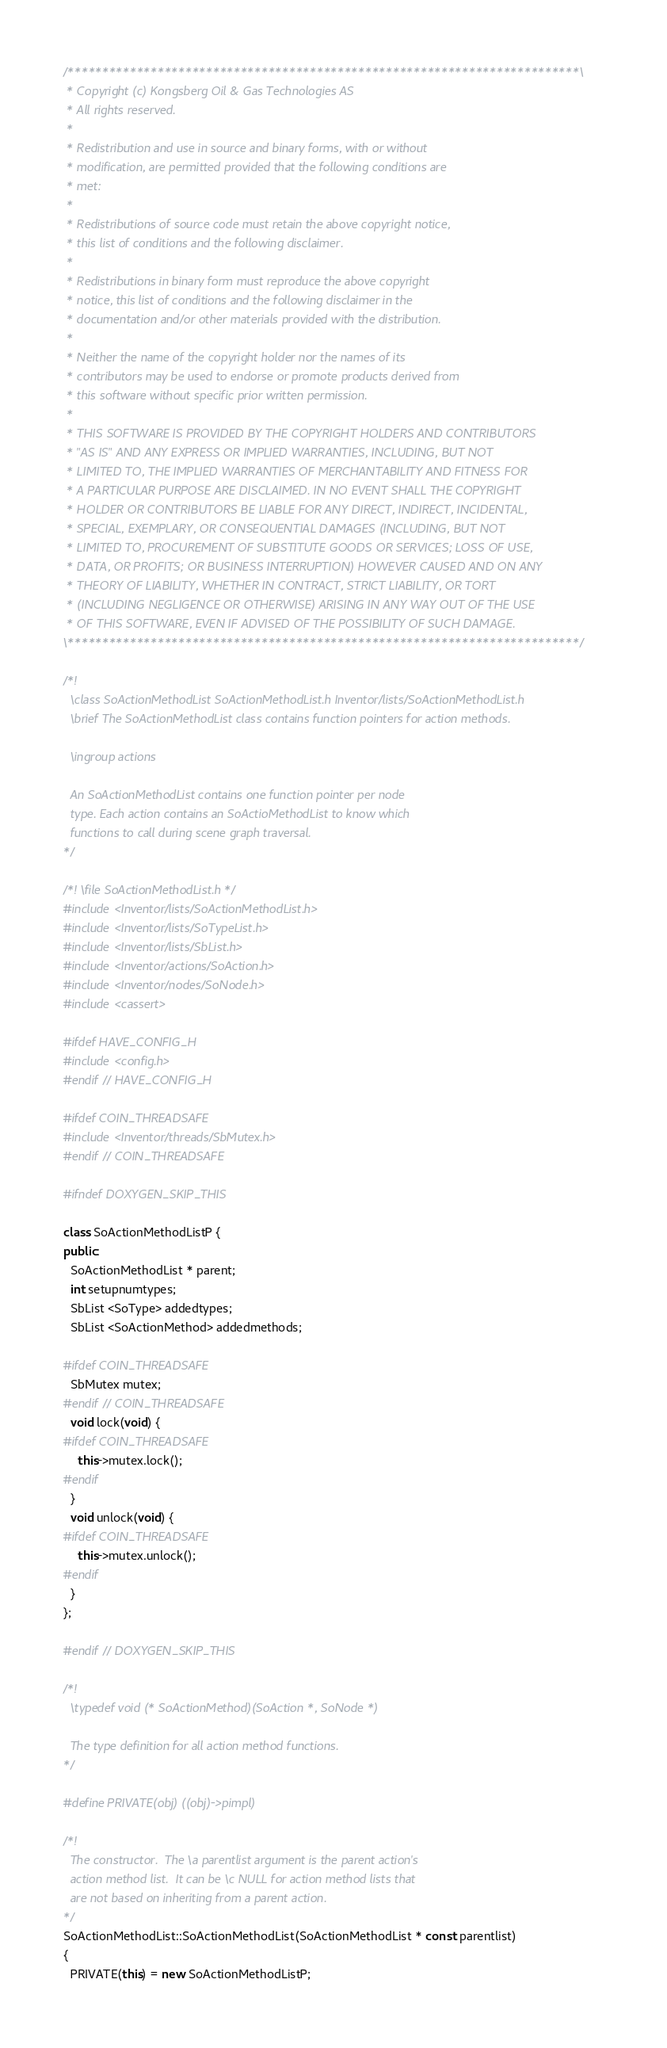Convert code to text. <code><loc_0><loc_0><loc_500><loc_500><_C++_>/**************************************************************************\
 * Copyright (c) Kongsberg Oil & Gas Technologies AS
 * All rights reserved.
 * 
 * Redistribution and use in source and binary forms, with or without
 * modification, are permitted provided that the following conditions are
 * met:
 * 
 * Redistributions of source code must retain the above copyright notice,
 * this list of conditions and the following disclaimer.
 * 
 * Redistributions in binary form must reproduce the above copyright
 * notice, this list of conditions and the following disclaimer in the
 * documentation and/or other materials provided with the distribution.
 * 
 * Neither the name of the copyright holder nor the names of its
 * contributors may be used to endorse or promote products derived from
 * this software without specific prior written permission.
 * 
 * THIS SOFTWARE IS PROVIDED BY THE COPYRIGHT HOLDERS AND CONTRIBUTORS
 * "AS IS" AND ANY EXPRESS OR IMPLIED WARRANTIES, INCLUDING, BUT NOT
 * LIMITED TO, THE IMPLIED WARRANTIES OF MERCHANTABILITY AND FITNESS FOR
 * A PARTICULAR PURPOSE ARE DISCLAIMED. IN NO EVENT SHALL THE COPYRIGHT
 * HOLDER OR CONTRIBUTORS BE LIABLE FOR ANY DIRECT, INDIRECT, INCIDENTAL,
 * SPECIAL, EXEMPLARY, OR CONSEQUENTIAL DAMAGES (INCLUDING, BUT NOT
 * LIMITED TO, PROCUREMENT OF SUBSTITUTE GOODS OR SERVICES; LOSS OF USE,
 * DATA, OR PROFITS; OR BUSINESS INTERRUPTION) HOWEVER CAUSED AND ON ANY
 * THEORY OF LIABILITY, WHETHER IN CONTRACT, STRICT LIABILITY, OR TORT
 * (INCLUDING NEGLIGENCE OR OTHERWISE) ARISING IN ANY WAY OUT OF THE USE
 * OF THIS SOFTWARE, EVEN IF ADVISED OF THE POSSIBILITY OF SUCH DAMAGE.
\**************************************************************************/

/*!
  \class SoActionMethodList SoActionMethodList.h Inventor/lists/SoActionMethodList.h
  \brief The SoActionMethodList class contains function pointers for action methods.

  \ingroup actions

  An SoActionMethodList contains one function pointer per node
  type. Each action contains an SoActioMethodList to know which
  functions to call during scene graph traversal.
*/

/*! \file SoActionMethodList.h */
#include <Inventor/lists/SoActionMethodList.h>
#include <Inventor/lists/SoTypeList.h>
#include <Inventor/lists/SbList.h>
#include <Inventor/actions/SoAction.h>
#include <Inventor/nodes/SoNode.h>
#include <cassert>

#ifdef HAVE_CONFIG_H
#include <config.h>
#endif // HAVE_CONFIG_H

#ifdef COIN_THREADSAFE
#include <Inventor/threads/SbMutex.h>
#endif // COIN_THREADSAFE

#ifndef DOXYGEN_SKIP_THIS

class SoActionMethodListP {
public:
  SoActionMethodList * parent;
  int setupnumtypes;
  SbList <SoType> addedtypes;
  SbList <SoActionMethod> addedmethods;

#ifdef COIN_THREADSAFE
  SbMutex mutex;
#endif // COIN_THREADSAFE
  void lock(void) {
#ifdef COIN_THREADSAFE
    this->mutex.lock();
#endif
  }
  void unlock(void) {
#ifdef COIN_THREADSAFE
    this->mutex.unlock();
#endif
  }
};

#endif // DOXYGEN_SKIP_THIS

/*!
  \typedef void (* SoActionMethod)(SoAction *, SoNode *)

  The type definition for all action method functions.
*/

#define PRIVATE(obj) ((obj)->pimpl)

/*!
  The constructor.  The \a parentlist argument is the parent action's
  action method list.  It can be \c NULL for action method lists that
  are not based on inheriting from a parent action.
*/
SoActionMethodList::SoActionMethodList(SoActionMethodList * const parentlist)
{
  PRIVATE(this) = new SoActionMethodListP;</code> 